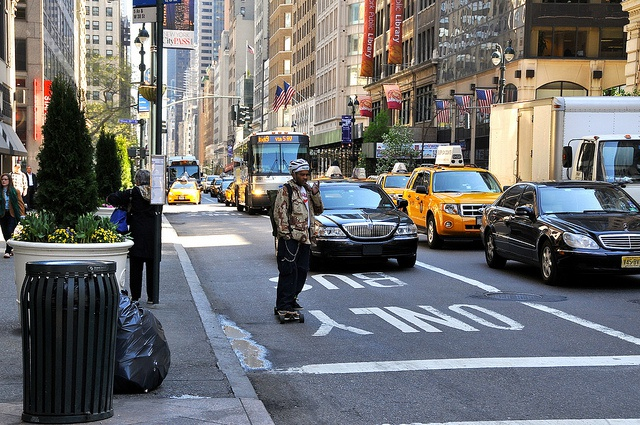Describe the objects in this image and their specific colors. I can see car in black, gray, lightblue, and darkgray tones, truck in black, lightgray, tan, and darkgray tones, car in black, gray, and lightblue tones, car in black, orange, ivory, and gray tones, and people in black, gray, darkgray, and maroon tones in this image. 